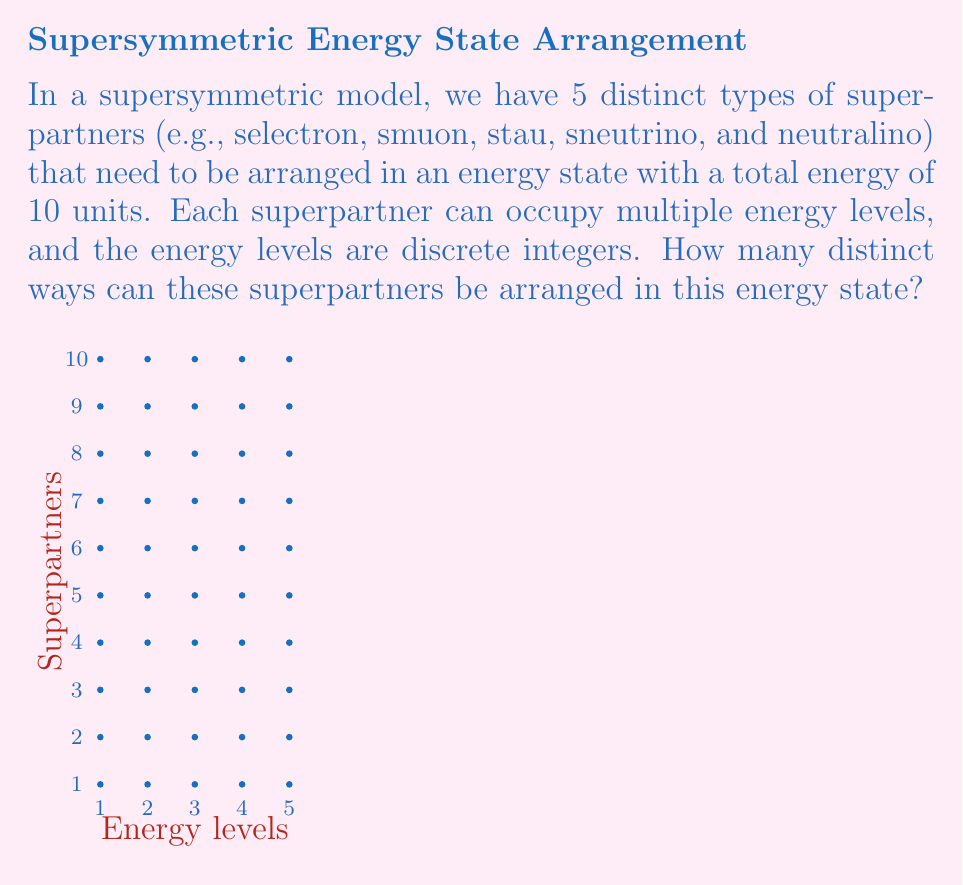Show me your answer to this math problem. To solve this problem, we can use partition theory and the concept of partitions with restricted parts.

1) First, we recognize that this problem is equivalent to finding the number of ways to partition the integer 10 into exactly 5 parts (corresponding to the 5 superpartners), where each part can be zero or a positive integer.

2) In partition theory, this is known as a composition of 10 into 5 parts, allowing zero parts.

3) The formula for the number of compositions of n into k parts, allowing zero parts, is:

   $$\binom{n+k-1}{k-1}$$

4) In our case, n = 10 (total energy) and k = 5 (number of superpartners). So we need to calculate:

   $$\binom{10+5-1}{5-1} = \binom{14}{4}$$

5) We can calculate this using the combination formula:

   $$\binom{14}{4} = \frac{14!}{4!(14-4)!} = \frac{14!}{4!10!}$$

6) Evaluating this:
   
   $$\frac{14 \cdot 13 \cdot 12 \cdot 11}{4 \cdot 3 \cdot 2 \cdot 1} = 1001$$

Therefore, there are 1001 distinct ways to arrange the superpartners in this energy state.
Answer: 1001 